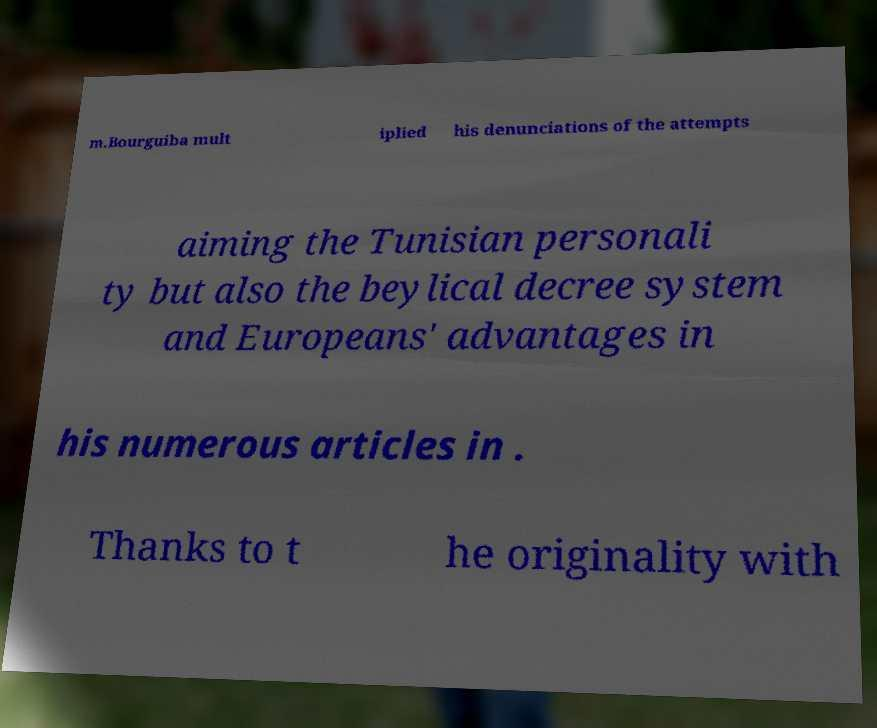I need the written content from this picture converted into text. Can you do that? m.Bourguiba mult iplied his denunciations of the attempts aiming the Tunisian personali ty but also the beylical decree system and Europeans' advantages in his numerous articles in . Thanks to t he originality with 